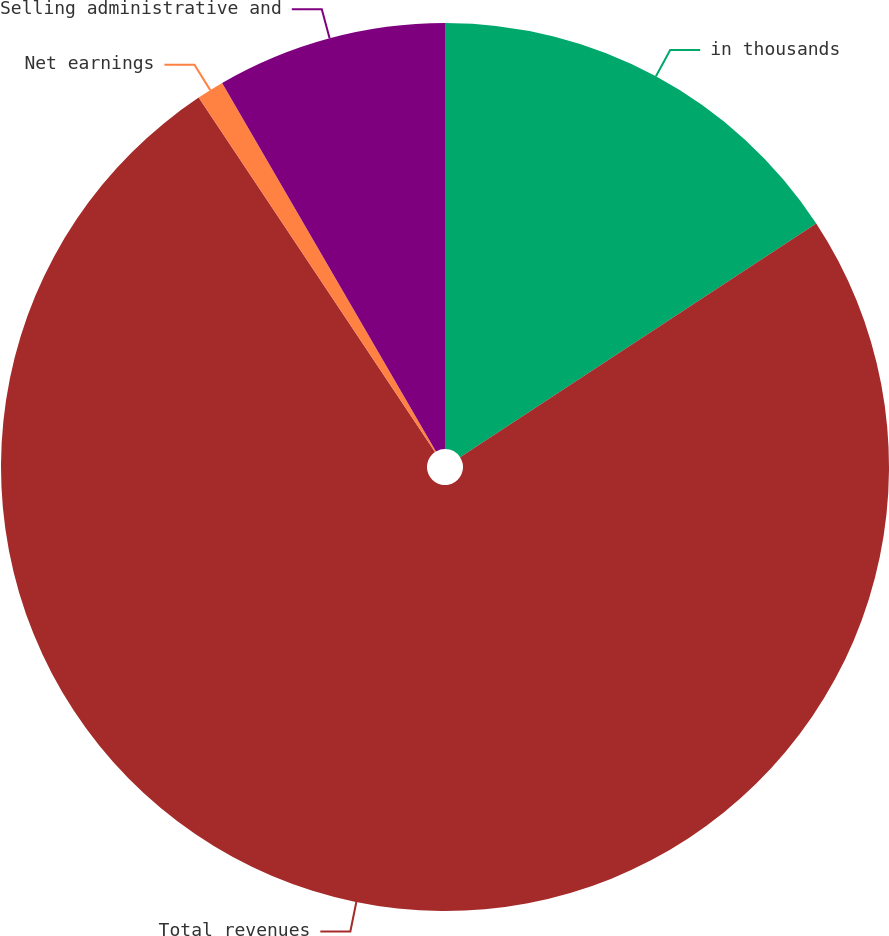<chart> <loc_0><loc_0><loc_500><loc_500><pie_chart><fcel>in thousands<fcel>Total revenues<fcel>Net earnings<fcel>Selling administrative and<nl><fcel>15.76%<fcel>74.88%<fcel>0.99%<fcel>8.37%<nl></chart> 